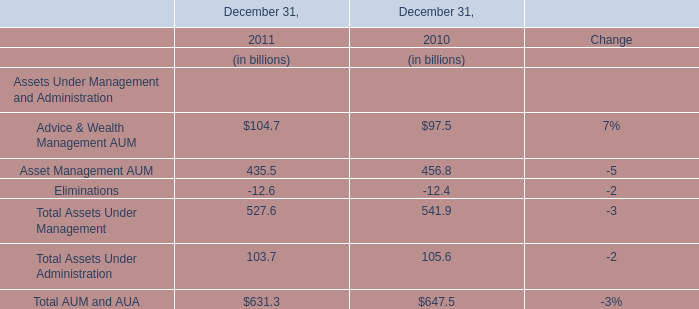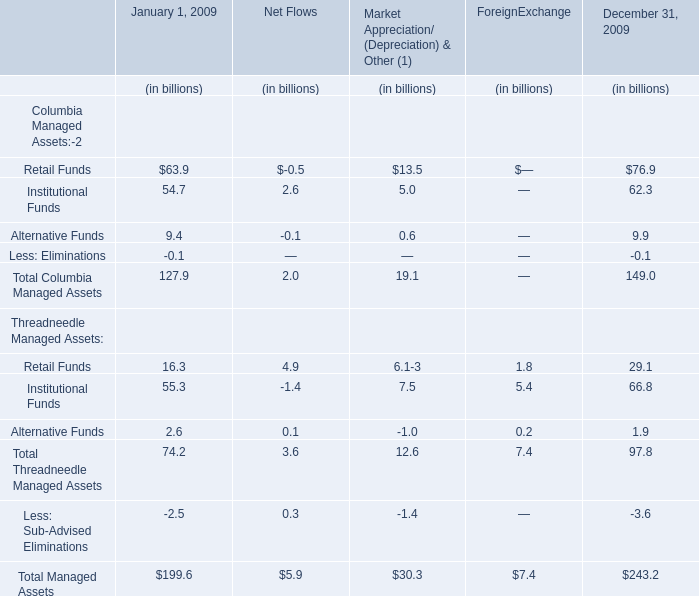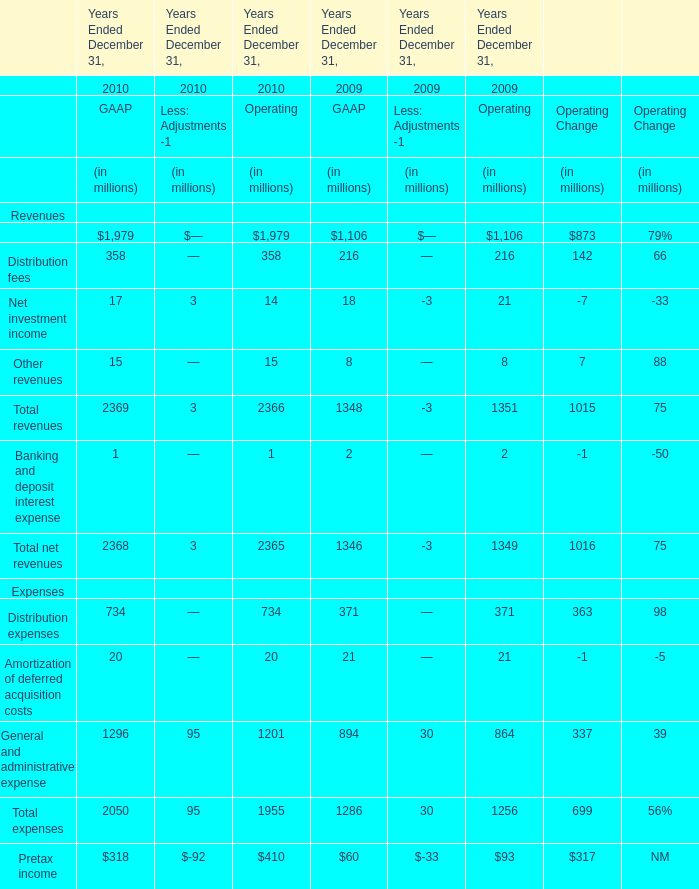What's the total amount of Columbia Managed Assets Funds in 2009? (in billion) 
Computations: (((127.9 + 2.0) + 19.1) + 149.0)
Answer: 298.0. 